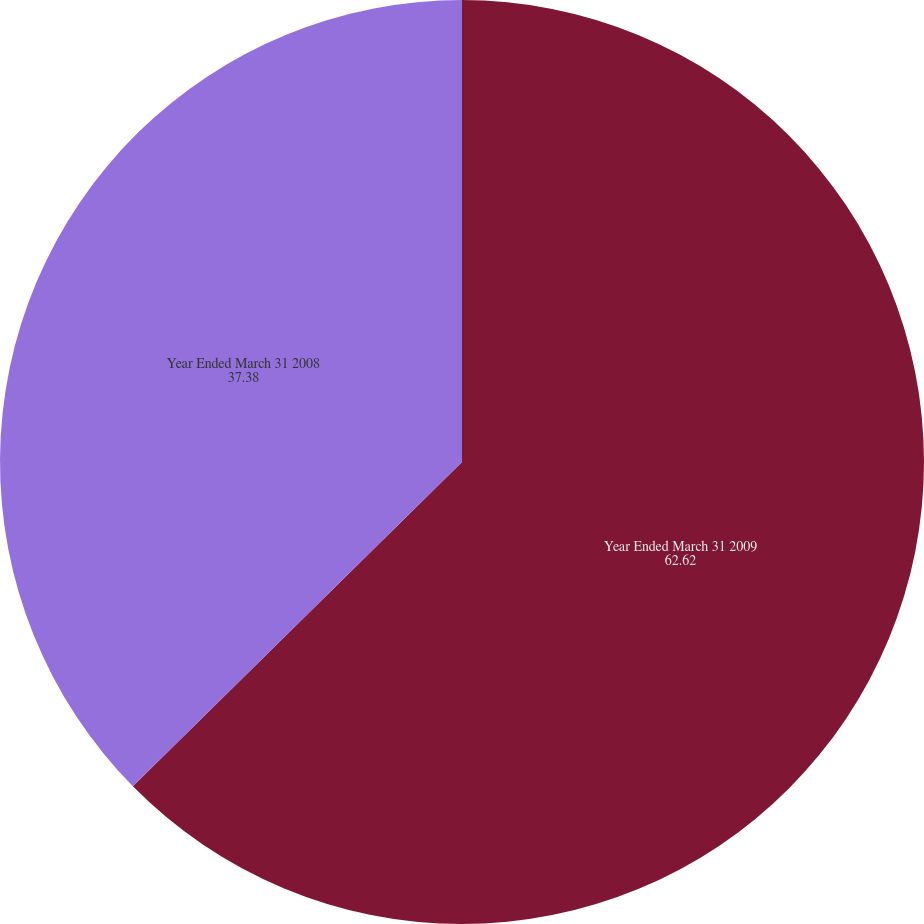Convert chart to OTSL. <chart><loc_0><loc_0><loc_500><loc_500><pie_chart><fcel>Year Ended March 31 2009<fcel>Year Ended March 31 2008<nl><fcel>62.62%<fcel>37.38%<nl></chart> 